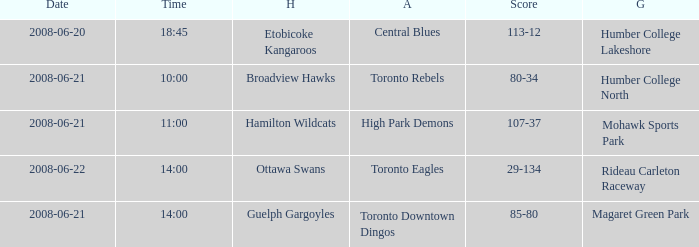What is the Away with a Ground that is humber college lakeshore? Central Blues. 